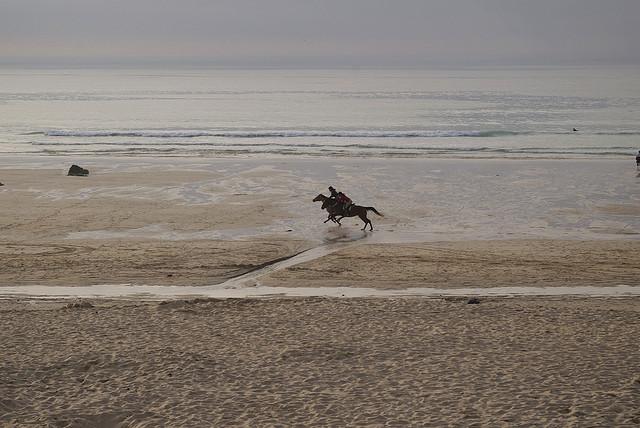Is this a beach?
Answer briefly. Yes. What is the man riding?
Write a very short answer. Horse. What is the man doing?
Write a very short answer. Riding horse. Are the horses running on dirt?
Short answer required. No. 